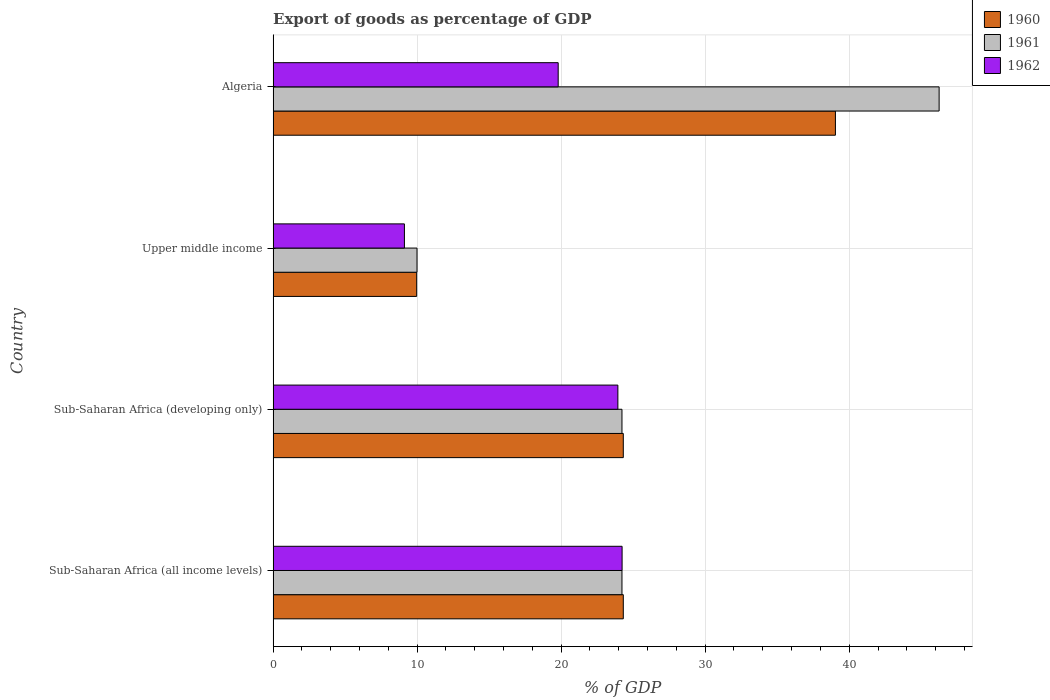How many different coloured bars are there?
Provide a succinct answer. 3. Are the number of bars per tick equal to the number of legend labels?
Give a very brief answer. Yes. How many bars are there on the 3rd tick from the bottom?
Provide a short and direct response. 3. What is the label of the 3rd group of bars from the top?
Give a very brief answer. Sub-Saharan Africa (developing only). What is the export of goods as percentage of GDP in 1961 in Sub-Saharan Africa (developing only)?
Offer a very short reply. 24.22. Across all countries, what is the maximum export of goods as percentage of GDP in 1962?
Offer a very short reply. 24.23. Across all countries, what is the minimum export of goods as percentage of GDP in 1961?
Offer a very short reply. 9.99. In which country was the export of goods as percentage of GDP in 1962 maximum?
Ensure brevity in your answer.  Sub-Saharan Africa (all income levels). In which country was the export of goods as percentage of GDP in 1962 minimum?
Your answer should be very brief. Upper middle income. What is the total export of goods as percentage of GDP in 1961 in the graph?
Make the answer very short. 104.68. What is the difference between the export of goods as percentage of GDP in 1962 in Sub-Saharan Africa (all income levels) and that in Upper middle income?
Give a very brief answer. 15.11. What is the difference between the export of goods as percentage of GDP in 1961 in Algeria and the export of goods as percentage of GDP in 1962 in Sub-Saharan Africa (all income levels)?
Your response must be concise. 22.01. What is the average export of goods as percentage of GDP in 1960 per country?
Your answer should be compact. 24.41. What is the difference between the export of goods as percentage of GDP in 1962 and export of goods as percentage of GDP in 1961 in Sub-Saharan Africa (all income levels)?
Your answer should be compact. 0.01. In how many countries, is the export of goods as percentage of GDP in 1960 greater than 38 %?
Ensure brevity in your answer.  1. What is the ratio of the export of goods as percentage of GDP in 1960 in Sub-Saharan Africa (all income levels) to that in Upper middle income?
Give a very brief answer. 2.44. Is the export of goods as percentage of GDP in 1962 in Sub-Saharan Africa (all income levels) less than that in Upper middle income?
Your answer should be compact. No. What is the difference between the highest and the second highest export of goods as percentage of GDP in 1961?
Your answer should be compact. 22.02. What is the difference between the highest and the lowest export of goods as percentage of GDP in 1962?
Offer a terse response. 15.11. In how many countries, is the export of goods as percentage of GDP in 1961 greater than the average export of goods as percentage of GDP in 1961 taken over all countries?
Your response must be concise. 1. How many bars are there?
Provide a short and direct response. 12. How many countries are there in the graph?
Ensure brevity in your answer.  4. What is the title of the graph?
Ensure brevity in your answer.  Export of goods as percentage of GDP. What is the label or title of the X-axis?
Provide a short and direct response. % of GDP. What is the label or title of the Y-axis?
Ensure brevity in your answer.  Country. What is the % of GDP of 1960 in Sub-Saharan Africa (all income levels)?
Give a very brief answer. 24.31. What is the % of GDP of 1961 in Sub-Saharan Africa (all income levels)?
Give a very brief answer. 24.22. What is the % of GDP in 1962 in Sub-Saharan Africa (all income levels)?
Keep it short and to the point. 24.23. What is the % of GDP in 1960 in Sub-Saharan Africa (developing only)?
Your answer should be compact. 24.31. What is the % of GDP in 1961 in Sub-Saharan Africa (developing only)?
Give a very brief answer. 24.22. What is the % of GDP in 1962 in Sub-Saharan Africa (developing only)?
Your answer should be compact. 23.94. What is the % of GDP in 1960 in Upper middle income?
Offer a terse response. 9.97. What is the % of GDP in 1961 in Upper middle income?
Offer a terse response. 9.99. What is the % of GDP of 1962 in Upper middle income?
Keep it short and to the point. 9.12. What is the % of GDP in 1960 in Algeria?
Offer a very short reply. 39.04. What is the % of GDP in 1961 in Algeria?
Make the answer very short. 46.24. What is the % of GDP of 1962 in Algeria?
Provide a succinct answer. 19.79. Across all countries, what is the maximum % of GDP of 1960?
Your answer should be very brief. 39.04. Across all countries, what is the maximum % of GDP of 1961?
Your answer should be compact. 46.24. Across all countries, what is the maximum % of GDP in 1962?
Ensure brevity in your answer.  24.23. Across all countries, what is the minimum % of GDP in 1960?
Keep it short and to the point. 9.97. Across all countries, what is the minimum % of GDP in 1961?
Ensure brevity in your answer.  9.99. Across all countries, what is the minimum % of GDP of 1962?
Offer a very short reply. 9.12. What is the total % of GDP of 1960 in the graph?
Your answer should be very brief. 97.64. What is the total % of GDP in 1961 in the graph?
Keep it short and to the point. 104.68. What is the total % of GDP in 1962 in the graph?
Offer a terse response. 77.08. What is the difference between the % of GDP of 1961 in Sub-Saharan Africa (all income levels) and that in Sub-Saharan Africa (developing only)?
Offer a terse response. 0. What is the difference between the % of GDP of 1962 in Sub-Saharan Africa (all income levels) and that in Sub-Saharan Africa (developing only)?
Offer a terse response. 0.29. What is the difference between the % of GDP in 1960 in Sub-Saharan Africa (all income levels) and that in Upper middle income?
Ensure brevity in your answer.  14.35. What is the difference between the % of GDP of 1961 in Sub-Saharan Africa (all income levels) and that in Upper middle income?
Give a very brief answer. 14.23. What is the difference between the % of GDP of 1962 in Sub-Saharan Africa (all income levels) and that in Upper middle income?
Offer a very short reply. 15.11. What is the difference between the % of GDP in 1960 in Sub-Saharan Africa (all income levels) and that in Algeria?
Your answer should be very brief. -14.73. What is the difference between the % of GDP of 1961 in Sub-Saharan Africa (all income levels) and that in Algeria?
Provide a short and direct response. -22.02. What is the difference between the % of GDP of 1962 in Sub-Saharan Africa (all income levels) and that in Algeria?
Your answer should be very brief. 4.44. What is the difference between the % of GDP of 1960 in Sub-Saharan Africa (developing only) and that in Upper middle income?
Ensure brevity in your answer.  14.35. What is the difference between the % of GDP in 1961 in Sub-Saharan Africa (developing only) and that in Upper middle income?
Make the answer very short. 14.23. What is the difference between the % of GDP in 1962 in Sub-Saharan Africa (developing only) and that in Upper middle income?
Offer a terse response. 14.82. What is the difference between the % of GDP in 1960 in Sub-Saharan Africa (developing only) and that in Algeria?
Offer a terse response. -14.73. What is the difference between the % of GDP of 1961 in Sub-Saharan Africa (developing only) and that in Algeria?
Provide a succinct answer. -22.02. What is the difference between the % of GDP of 1962 in Sub-Saharan Africa (developing only) and that in Algeria?
Give a very brief answer. 4.14. What is the difference between the % of GDP in 1960 in Upper middle income and that in Algeria?
Provide a short and direct response. -29.08. What is the difference between the % of GDP in 1961 in Upper middle income and that in Algeria?
Your answer should be very brief. -36.25. What is the difference between the % of GDP in 1962 in Upper middle income and that in Algeria?
Give a very brief answer. -10.68. What is the difference between the % of GDP of 1960 in Sub-Saharan Africa (all income levels) and the % of GDP of 1961 in Sub-Saharan Africa (developing only)?
Keep it short and to the point. 0.09. What is the difference between the % of GDP in 1960 in Sub-Saharan Africa (all income levels) and the % of GDP in 1962 in Sub-Saharan Africa (developing only)?
Provide a succinct answer. 0.38. What is the difference between the % of GDP in 1961 in Sub-Saharan Africa (all income levels) and the % of GDP in 1962 in Sub-Saharan Africa (developing only)?
Offer a terse response. 0.28. What is the difference between the % of GDP of 1960 in Sub-Saharan Africa (all income levels) and the % of GDP of 1961 in Upper middle income?
Provide a succinct answer. 14.32. What is the difference between the % of GDP in 1960 in Sub-Saharan Africa (all income levels) and the % of GDP in 1962 in Upper middle income?
Ensure brevity in your answer.  15.2. What is the difference between the % of GDP of 1961 in Sub-Saharan Africa (all income levels) and the % of GDP of 1962 in Upper middle income?
Provide a short and direct response. 15.11. What is the difference between the % of GDP in 1960 in Sub-Saharan Africa (all income levels) and the % of GDP in 1961 in Algeria?
Your response must be concise. -21.93. What is the difference between the % of GDP in 1960 in Sub-Saharan Africa (all income levels) and the % of GDP in 1962 in Algeria?
Provide a succinct answer. 4.52. What is the difference between the % of GDP in 1961 in Sub-Saharan Africa (all income levels) and the % of GDP in 1962 in Algeria?
Your response must be concise. 4.43. What is the difference between the % of GDP in 1960 in Sub-Saharan Africa (developing only) and the % of GDP in 1961 in Upper middle income?
Your response must be concise. 14.32. What is the difference between the % of GDP of 1960 in Sub-Saharan Africa (developing only) and the % of GDP of 1962 in Upper middle income?
Your answer should be very brief. 15.2. What is the difference between the % of GDP of 1961 in Sub-Saharan Africa (developing only) and the % of GDP of 1962 in Upper middle income?
Your answer should be very brief. 15.11. What is the difference between the % of GDP of 1960 in Sub-Saharan Africa (developing only) and the % of GDP of 1961 in Algeria?
Provide a short and direct response. -21.93. What is the difference between the % of GDP in 1960 in Sub-Saharan Africa (developing only) and the % of GDP in 1962 in Algeria?
Provide a short and direct response. 4.52. What is the difference between the % of GDP in 1961 in Sub-Saharan Africa (developing only) and the % of GDP in 1962 in Algeria?
Provide a short and direct response. 4.43. What is the difference between the % of GDP of 1960 in Upper middle income and the % of GDP of 1961 in Algeria?
Offer a terse response. -36.28. What is the difference between the % of GDP in 1960 in Upper middle income and the % of GDP in 1962 in Algeria?
Offer a terse response. -9.83. What is the difference between the % of GDP of 1961 in Upper middle income and the % of GDP of 1962 in Algeria?
Make the answer very short. -9.8. What is the average % of GDP in 1960 per country?
Make the answer very short. 24.41. What is the average % of GDP in 1961 per country?
Ensure brevity in your answer.  26.17. What is the average % of GDP in 1962 per country?
Keep it short and to the point. 19.27. What is the difference between the % of GDP of 1960 and % of GDP of 1961 in Sub-Saharan Africa (all income levels)?
Provide a succinct answer. 0.09. What is the difference between the % of GDP of 1960 and % of GDP of 1962 in Sub-Saharan Africa (all income levels)?
Provide a succinct answer. 0.08. What is the difference between the % of GDP in 1961 and % of GDP in 1962 in Sub-Saharan Africa (all income levels)?
Give a very brief answer. -0.01. What is the difference between the % of GDP in 1960 and % of GDP in 1961 in Sub-Saharan Africa (developing only)?
Ensure brevity in your answer.  0.09. What is the difference between the % of GDP of 1960 and % of GDP of 1962 in Sub-Saharan Africa (developing only)?
Ensure brevity in your answer.  0.38. What is the difference between the % of GDP in 1961 and % of GDP in 1962 in Sub-Saharan Africa (developing only)?
Provide a short and direct response. 0.28. What is the difference between the % of GDP of 1960 and % of GDP of 1961 in Upper middle income?
Ensure brevity in your answer.  -0.02. What is the difference between the % of GDP in 1960 and % of GDP in 1962 in Upper middle income?
Your answer should be compact. 0.85. What is the difference between the % of GDP in 1961 and % of GDP in 1962 in Upper middle income?
Provide a succinct answer. 0.87. What is the difference between the % of GDP in 1960 and % of GDP in 1961 in Algeria?
Give a very brief answer. -7.2. What is the difference between the % of GDP of 1960 and % of GDP of 1962 in Algeria?
Make the answer very short. 19.25. What is the difference between the % of GDP of 1961 and % of GDP of 1962 in Algeria?
Offer a terse response. 26.45. What is the ratio of the % of GDP of 1960 in Sub-Saharan Africa (all income levels) to that in Sub-Saharan Africa (developing only)?
Ensure brevity in your answer.  1. What is the ratio of the % of GDP of 1961 in Sub-Saharan Africa (all income levels) to that in Sub-Saharan Africa (developing only)?
Give a very brief answer. 1. What is the ratio of the % of GDP in 1962 in Sub-Saharan Africa (all income levels) to that in Sub-Saharan Africa (developing only)?
Your answer should be very brief. 1.01. What is the ratio of the % of GDP of 1960 in Sub-Saharan Africa (all income levels) to that in Upper middle income?
Make the answer very short. 2.44. What is the ratio of the % of GDP in 1961 in Sub-Saharan Africa (all income levels) to that in Upper middle income?
Provide a succinct answer. 2.42. What is the ratio of the % of GDP in 1962 in Sub-Saharan Africa (all income levels) to that in Upper middle income?
Offer a very short reply. 2.66. What is the ratio of the % of GDP of 1960 in Sub-Saharan Africa (all income levels) to that in Algeria?
Provide a succinct answer. 0.62. What is the ratio of the % of GDP of 1961 in Sub-Saharan Africa (all income levels) to that in Algeria?
Your answer should be very brief. 0.52. What is the ratio of the % of GDP of 1962 in Sub-Saharan Africa (all income levels) to that in Algeria?
Ensure brevity in your answer.  1.22. What is the ratio of the % of GDP in 1960 in Sub-Saharan Africa (developing only) to that in Upper middle income?
Keep it short and to the point. 2.44. What is the ratio of the % of GDP of 1961 in Sub-Saharan Africa (developing only) to that in Upper middle income?
Give a very brief answer. 2.42. What is the ratio of the % of GDP in 1962 in Sub-Saharan Africa (developing only) to that in Upper middle income?
Ensure brevity in your answer.  2.63. What is the ratio of the % of GDP in 1960 in Sub-Saharan Africa (developing only) to that in Algeria?
Your response must be concise. 0.62. What is the ratio of the % of GDP in 1961 in Sub-Saharan Africa (developing only) to that in Algeria?
Offer a very short reply. 0.52. What is the ratio of the % of GDP in 1962 in Sub-Saharan Africa (developing only) to that in Algeria?
Keep it short and to the point. 1.21. What is the ratio of the % of GDP of 1960 in Upper middle income to that in Algeria?
Keep it short and to the point. 0.26. What is the ratio of the % of GDP in 1961 in Upper middle income to that in Algeria?
Your answer should be compact. 0.22. What is the ratio of the % of GDP in 1962 in Upper middle income to that in Algeria?
Ensure brevity in your answer.  0.46. What is the difference between the highest and the second highest % of GDP of 1960?
Give a very brief answer. 14.73. What is the difference between the highest and the second highest % of GDP in 1961?
Provide a succinct answer. 22.02. What is the difference between the highest and the second highest % of GDP of 1962?
Your answer should be compact. 0.29. What is the difference between the highest and the lowest % of GDP in 1960?
Keep it short and to the point. 29.08. What is the difference between the highest and the lowest % of GDP in 1961?
Your response must be concise. 36.25. What is the difference between the highest and the lowest % of GDP in 1962?
Offer a very short reply. 15.11. 